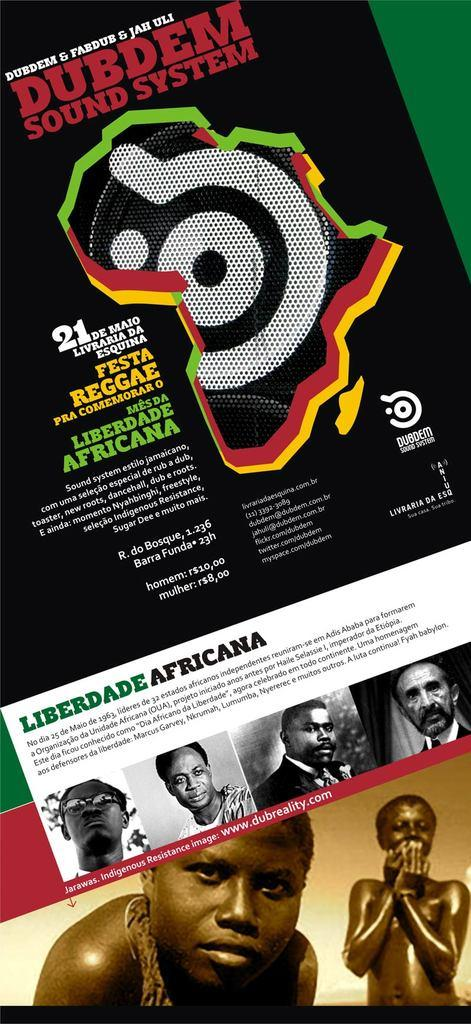What type of image is being described? The image is a poster. What can be seen on the poster? There are depictions of people on the poster. Are there any words on the poster? Yes, there is text on the poster. How does the crook help the people on the poster? There is no crook present in the image; it is a poster with depictions of people and text. 